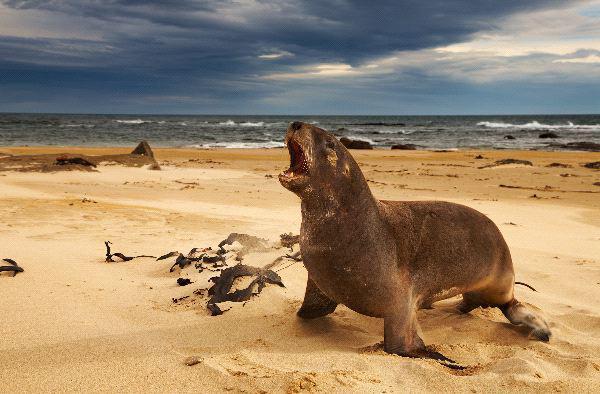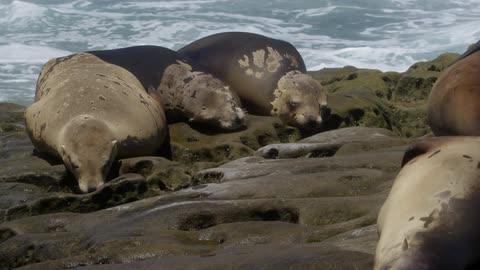The first image is the image on the left, the second image is the image on the right. Examine the images to the left and right. Is the description "There are more seals in the image on the right." accurate? Answer yes or no. Yes. The first image is the image on the left, the second image is the image on the right. Examine the images to the left and right. Is the description "An image includes a seal in the foreground with its mouth open and head upside-down." accurate? Answer yes or no. No. 